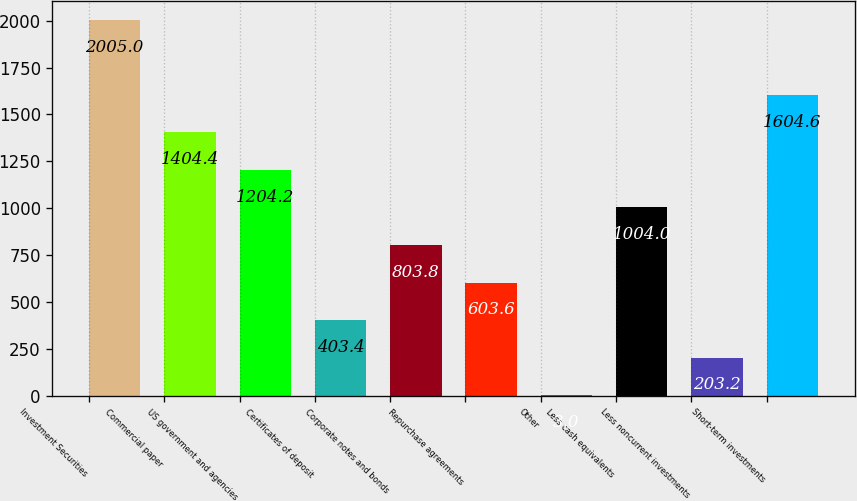Convert chart. <chart><loc_0><loc_0><loc_500><loc_500><bar_chart><fcel>Investment Securities<fcel>Commercial paper<fcel>US government and agencies<fcel>Certificates of deposit<fcel>Corporate notes and bonds<fcel>Repurchase agreements<fcel>Other<fcel>Less cash equivalents<fcel>Less noncurrent investments<fcel>Short-term investments<nl><fcel>2005<fcel>1404.4<fcel>1204.2<fcel>403.4<fcel>803.8<fcel>603.6<fcel>3<fcel>1004<fcel>203.2<fcel>1604.6<nl></chart> 